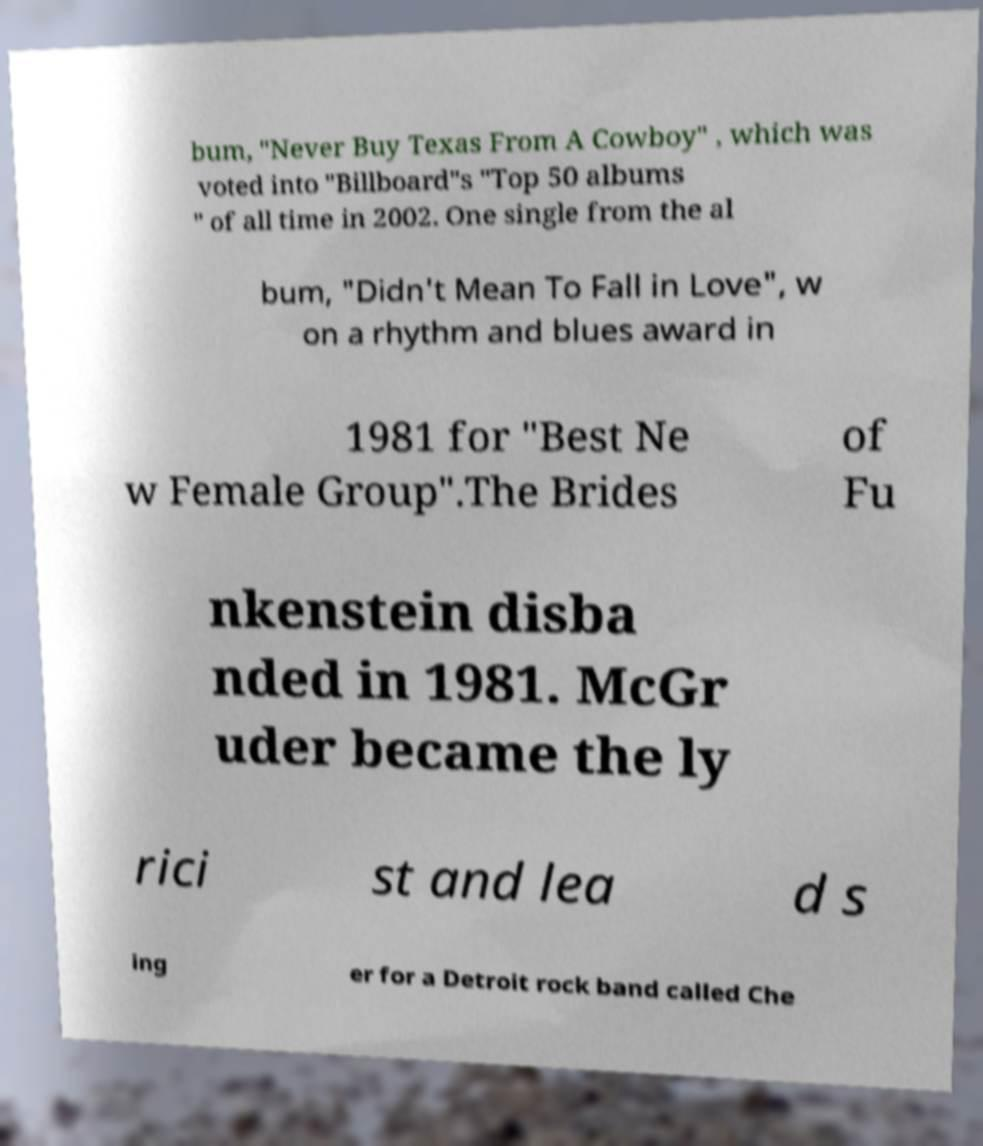Can you read and provide the text displayed in the image?This photo seems to have some interesting text. Can you extract and type it out for me? bum, "Never Buy Texas From A Cowboy" , which was voted into "Billboard"s "Top 50 albums " of all time in 2002. One single from the al bum, "Didn't Mean To Fall in Love", w on a rhythm and blues award in 1981 for "Best Ne w Female Group".The Brides of Fu nkenstein disba nded in 1981. McGr uder became the ly rici st and lea d s ing er for a Detroit rock band called Che 